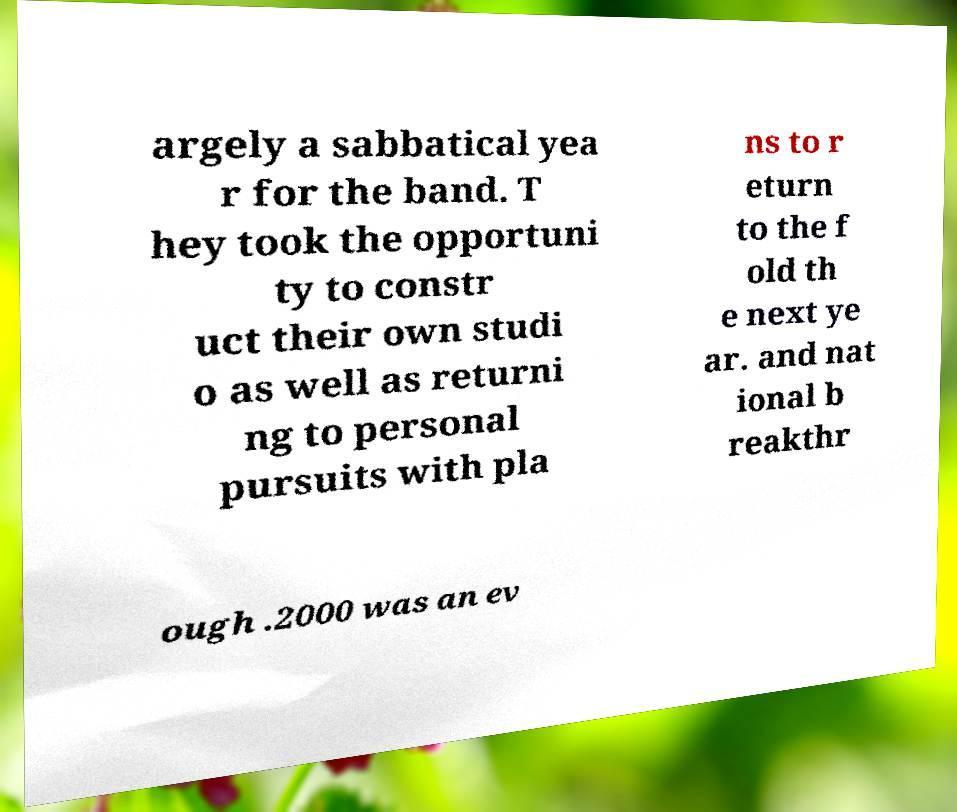Could you extract and type out the text from this image? argely a sabbatical yea r for the band. T hey took the opportuni ty to constr uct their own studi o as well as returni ng to personal pursuits with pla ns to r eturn to the f old th e next ye ar. and nat ional b reakthr ough .2000 was an ev 